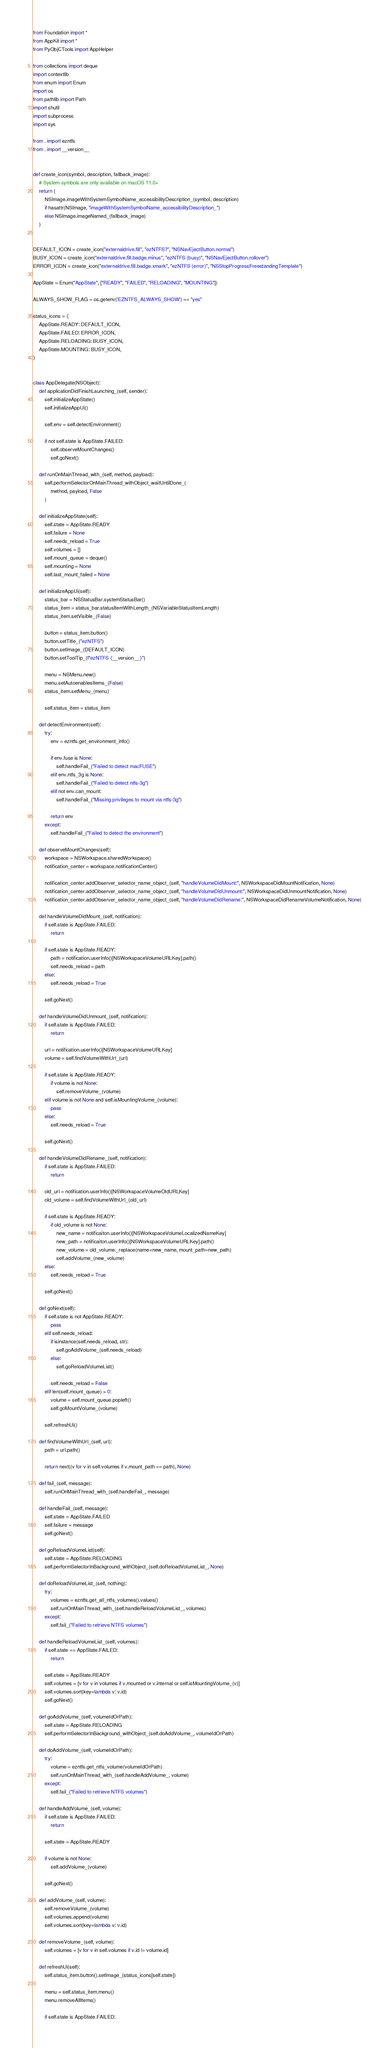<code> <loc_0><loc_0><loc_500><loc_500><_Python_>from Foundation import *
from AppKit import *
from PyObjCTools import AppHelper

from collections import deque
import contextlib
from enum import Enum
import os
from pathlib import Path
import shutil
import subprocess
import sys

from . import ezntfs
from . import __version__


def create_icon(symbol, description, fallback_image):
    # System symbols are only available on macOS 11.0+
    return (
        NSImage.imageWithSystemSymbolName_accessibilityDescription_(symbol, description)
        if hasattr(NSImage, "imageWithSystemSymbolName_accessibilityDescription_")
        else NSImage.imageNamed_(fallback_image)
    )


DEFAULT_ICON = create_icon("externaldrive.fill", "ezNTFS?", "NSNavEjectButton.normal")
BUSY_ICON = create_icon("externaldrive.fill.badge.minus", "ezNTFS (busy)", "NSNavEjectButton.rollover")
ERROR_ICON = create_icon("externaldrive.fill.badge.xmark", "ezNTFS (error)", "NSStopProgressFreestandingTemplate")

AppState = Enum("AppState", ["READY", "FAILED", "RELOADING", "MOUNTING"])

ALWAYS_SHOW_FLAG = os.getenv('EZNTFS_ALWAYS_SHOW') == "yes"

status_icons = {
    AppState.READY: DEFAULT_ICON,
    AppState.FAILED: ERROR_ICON,
    AppState.RELOADING: BUSY_ICON,
    AppState.MOUNTING: BUSY_ICON,
}


class AppDelegate(NSObject):
    def applicationDidFinishLaunching_(self, sender):
        self.initializeAppState()
        self.initializeAppUi()

        self.env = self.detectEnvironment()

        if not self.state is AppState.FAILED:
            self.observeMountChanges()
            self.goNext()

    def runOnMainThread_with_(self, method, payload):
        self.performSelectorOnMainThread_withObject_waitUntilDone_(
            method, payload, False
        )

    def initializeAppState(self):
        self.state = AppState.READY
        self.failure = None
        self.needs_reload = True
        self.volumes = []
        self.mount_queue = deque()
        self.mounting = None
        self.last_mount_failed = None

    def initializeAppUi(self):
        status_bar = NSStatusBar.systemStatusBar()
        status_item = status_bar.statusItemWithLength_(NSVariableStatusItemLength)
        status_item.setVisible_(False)

        button = status_item.button()
        button.setTitle_("ezNTFS")
        button.setImage_(DEFAULT_ICON)
        button.setToolTip_(f"ezNTFS {__version__}")

        menu = NSMenu.new()
        menu.setAutoenablesItems_(False)
        status_item.setMenu_(menu)

        self.status_item = status_item

    def detectEnvironment(self):
        try:
            env = ezntfs.get_environment_info()

            if env.fuse is None:
                self.handleFail_("Failed to detect macFUSE")
            elif env.ntfs_3g is None:
                self.handleFail_("Failed to detect ntfs-3g")
            elif not env.can_mount:
                self.handleFail_("Missing privileges to mount via ntfs-3g")

            return env
        except:
            self.handleFail_("Failed to detect the environment")

    def observeMountChanges(self):
        workspace = NSWorkspace.sharedWorkspace()
        notification_center = workspace.notificationCenter()

        notification_center.addObserver_selector_name_object_(self, "handleVolumeDidMount:", NSWorkspaceDidMountNotification, None)
        notification_center.addObserver_selector_name_object_(self, "handleVolumeDidUnmount:", NSWorkspaceDidUnmountNotification, None)
        notification_center.addObserver_selector_name_object_(self, "handleVolumeDidRename:", NSWorkspaceDidRenameVolumeNotification, None)

    def handleVolumeDidMount_(self, notification):
        if self.state is AppState.FAILED:
            return

        if self.state is AppState.READY:
            path = notification.userInfo()[NSWorkspaceVolumeURLKey].path()
            self.needs_reload = path
        else:
            self.needs_reload = True

        self.goNext()

    def handleVolumeDidUnmount_(self, notification):
        if self.state is AppState.FAILED:
            return

        url = notification.userInfo()[NSWorkspaceVolumeURLKey]
        volume = self.findVolumeWithUrl_(url)

        if self.state is AppState.READY:
            if volume is not None:
                self.removeVolume_(volume)
        elif volume is not None and self.isMountingVolume_(volume):
            pass
        else:
            self.needs_reload = True

        self.goNext()

    def handleVolumeDidRename_(self, notification):
        if self.state is AppState.FAILED:
            return

        old_url = notification.userInfo()[NSWorkspaceVolumeOldURLKey]
        old_volume = self.findVolumeWithUrl_(old_url)

        if self.state is AppState.READY:
            if old_volume is not None:
                new_name = notificaiton.userInfo()[NSWorkspaceVolumeLocalizedNameKey]
                new_path = notificaiton.userInfo()[NSWorkspaceVolumeURLKey].path()
                new_volume = old_volume._replace(name=new_name, mount_path=new_path)
                self.addVolume_(new_volume)
        else:
            self.needs_reload = True

        self.goNext()

    def goNext(self):
        if self.state is not AppState.READY:
            pass
        elif self.needs_reload:
            if isinstance(self.needs_reload, str):
                self.goAddVolume_(self.needs_reload)
            else:
                self.goReloadVolumeList()

            self.needs_reload = False
        elif len(self.mount_queue) > 0:
            volume = self.mount_queue.popleft()
            self.goMountVolume_(volume)

        self.refreshUi()

    def findVolumeWithUrl_(self, url):
        path = url.path()

        return next((v for v in self.volumes if v.mount_path == path), None)

    def fail_(self, message):
        self.runOnMainThread_with_(self.handleFail_, message)

    def handleFail_(self, message):
        self.state = AppState.FAILED
        self.failure = message
        self.goNext()

    def goReloadVolumeList(self):
        self.state = AppState.RELOADING
        self.performSelectorInBackground_withObject_(self.doReloadVolumeList_, None)

    def doReloadVolumeList_(self, nothing):
        try:
            volumes = ezntfs.get_all_ntfs_volumes().values()
            self.runOnMainThread_with_(self.handleReloadVolumeList_, volumes)
        except:
            self.fail_("Failed to retrieve NTFS volumes")

    def handleReloadVolumeList_(self, volumes):
        if self.state == AppState.FAILED:
            return

        self.state = AppState.READY
        self.volumes = [v for v in volumes if v.mounted or v.internal or self.isMountingVolume_(v)]
        self.volumes.sort(key=lambda v: v.id)
        self.goNext()

    def goAddVolume_(self, volumeIdOrPath):
        self.state = AppState.RELOADING
        self.performSelectorInBackground_withObject_(self.doAddVolume_, volumeIdOrPath)

    def doAddVolume_(self, volumeIdOrPath):
        try:
            volume = ezntfs.get_ntfs_volume(volumeIdOrPath)
            self.runOnMainThread_with_(self.handleAddVolume_, volume)
        except:
            self.fail_("Failed to retrieve NTFS volumes")

    def handleAddVolume_(self, volume):
        if self.state is AppState.FAILED:
            return

        self.state = AppState.READY

        if volume is not None:
            self.addVolume_(volume)

        self.goNext()

    def addVolume_(self, volume):
        self.removeVolume_(volume)
        self.volumes.append(volume)
        self.volumes.sort(key=lambda v: v.id)

    def removeVolume_(self, volume):
        self.volumes = [v for v in self.volumes if v.id != volume.id]

    def refreshUi(self):
        self.status_item.button().setImage_(status_icons[self.state])

        menu = self.status_item.menu()
        menu.removeAllItems()

        if self.state is AppState.FAILED:</code> 